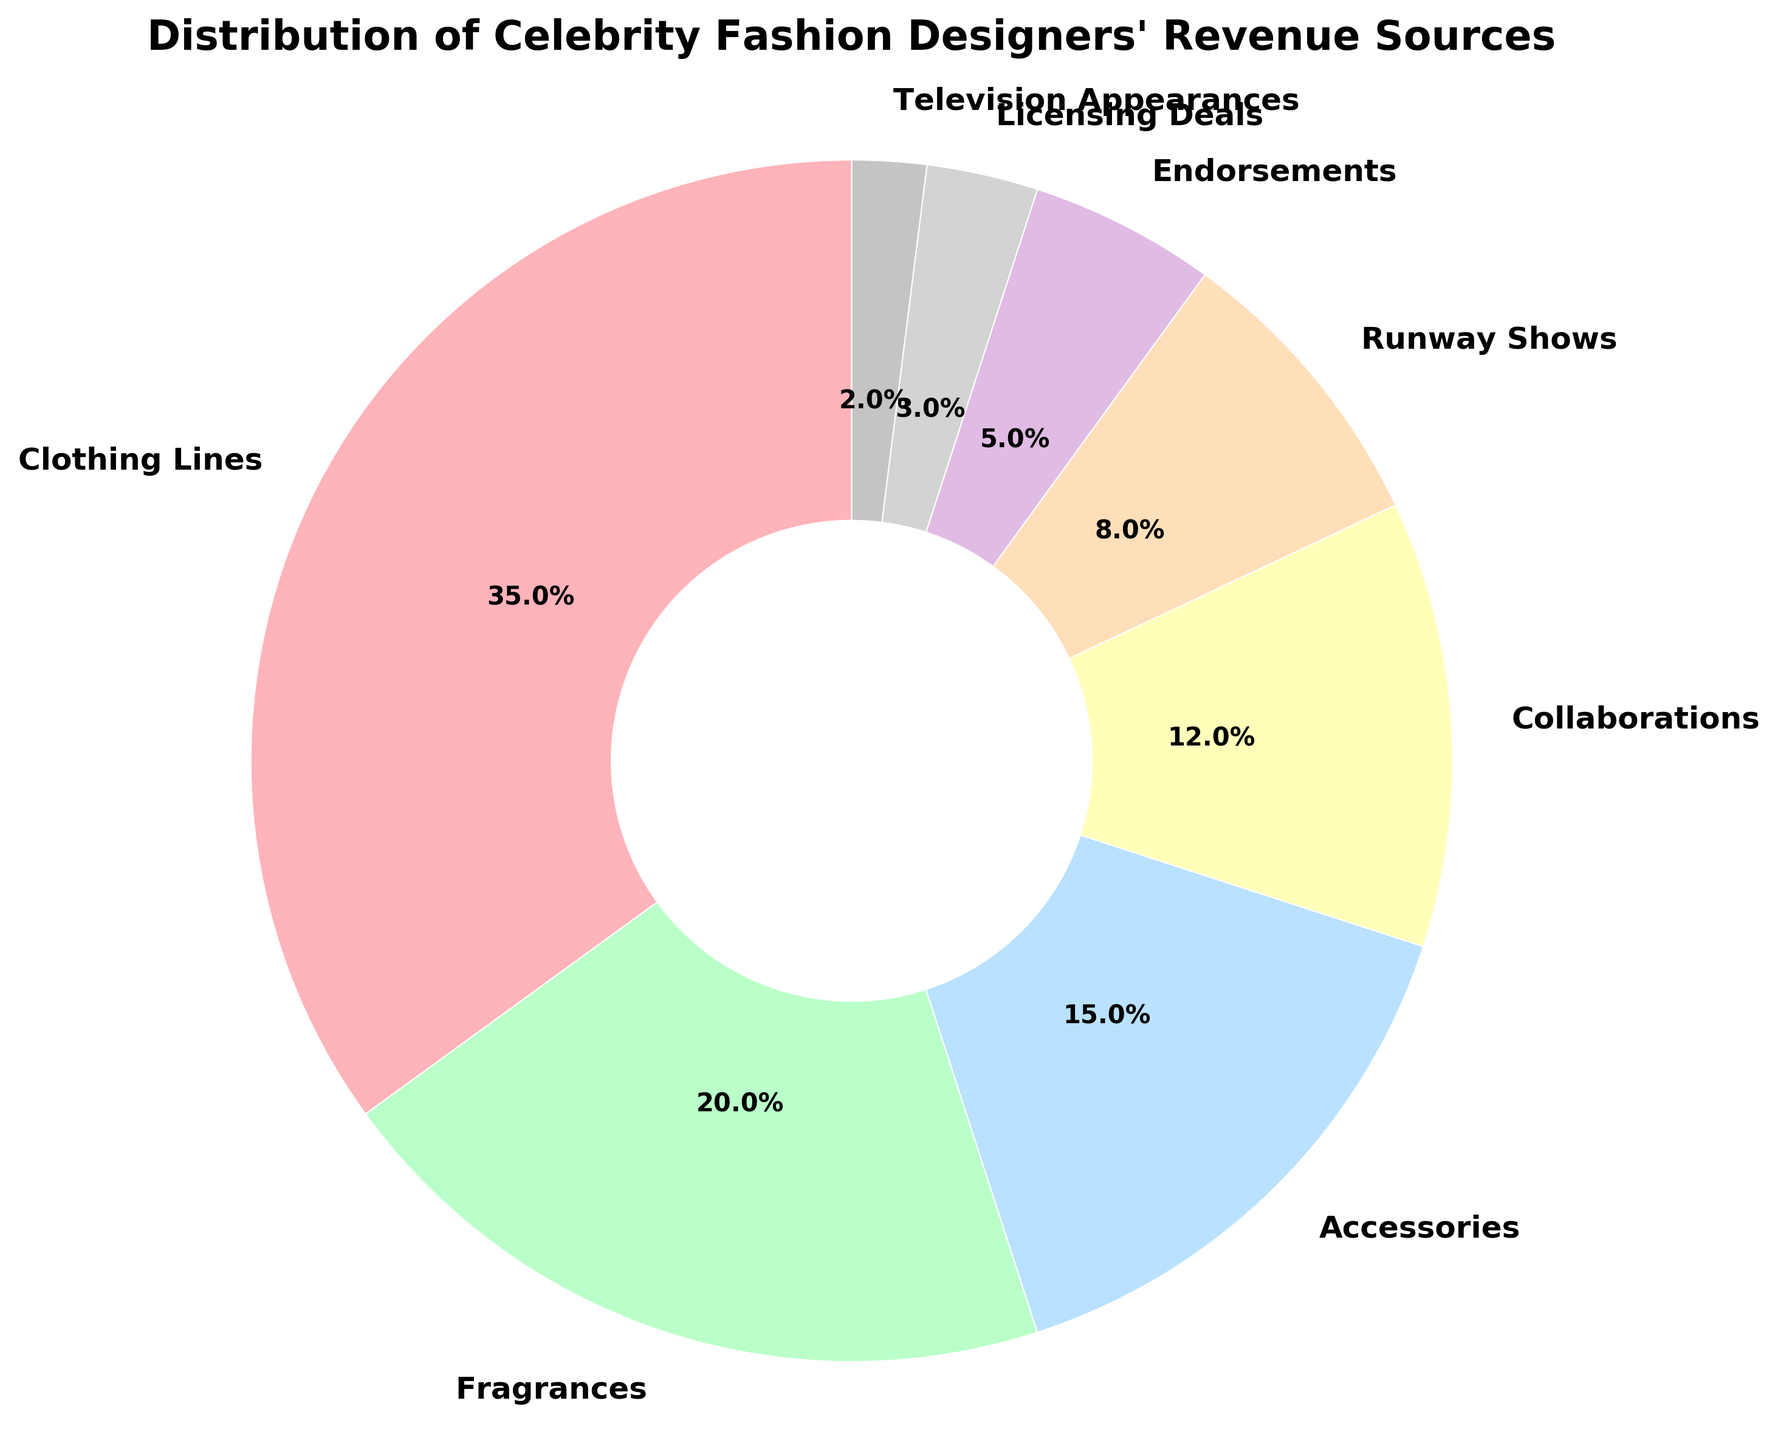what is the highest revenue source for celebrity fashion designers? The highest revenue source is represented by the largest segment in the pie chart. Observe which section takes up the largest portion. Here, it's the "Clothing Lines" category, which accounts for 35%.
Answer: Clothing Lines Which two categories make up a combined total of less than 10% of revenue? First, identify the percentages of each category and then sum the smaller values. The two smallest categories are "Licensing Deals" at 3% and "Television Appearances" at 2%. Their combined percentage is 3% + 2% = 5%, which is less than 10%.
Answer: Licensing Deals and Television Appearances What category generates more revenue: Accessories or Collaborations? Locate the sections for "Accessories" and "Collaborations" in the pie chart. "Accessories" accounts for 15% and "Collaborations" for 12%. Comparing these, 15% is greater than 12%, so "Accessories" generates more revenue.
Answer: Accessories What is the total revenue percentage generated from Fragrances, Accessories, and Collaborations combined? Identify each segment's percentage from the pie chart: "Fragrances" (20%), "Accessories" (15%), and "Collaborations" (12%). Sum them up: 20% + 15% + 12% = 47%.
Answer: 47% How much more revenue does Clothing Lines generate compared to Endorsements? Identify the segments for "Clothing Lines" (35%) and "Endorsements" (5%). Subtract the percentage of "Endorsements" from "Clothing Lines": 35% - 5% = 30%.
Answer: 30% Which category shows up in a pale pink color? Identify the pale pink segment in the pie chart. The corresponding label to this segment is "Clothing Lines.". This is indicated both by the largest segment colored in pale pink and the label beside it.
Answer: Clothing Lines What is the difference in revenue percentages between Runway Shows and Collaborations? Locate the segments for "Runway Shows" (8%) and "Collaborations" (12%). Subtract the percentage of "Runway Shows" from "Collaborations": 12% - 8% = 4%.
Answer: 4% Which categories together contribute to just under 50% of the total revenue? Start by summing the percentages of the largest categories to approach 50%. "Clothing Lines" (35%) and "Fragrances" (20%) collectively surpass 50%, so instead consider combining "Clothing Lines" (35%) with smaller contributions like "Runway Shows" (8%) and "Collaborations" (12%) which makes 35% + 8% + 12% = 55%. While "Clothing Lines" (35%) and "Accessories" (15%) give us 50%), summing these two major revenue sources together hits just under 50%.
Answer: Clothing Lines and Accessories 